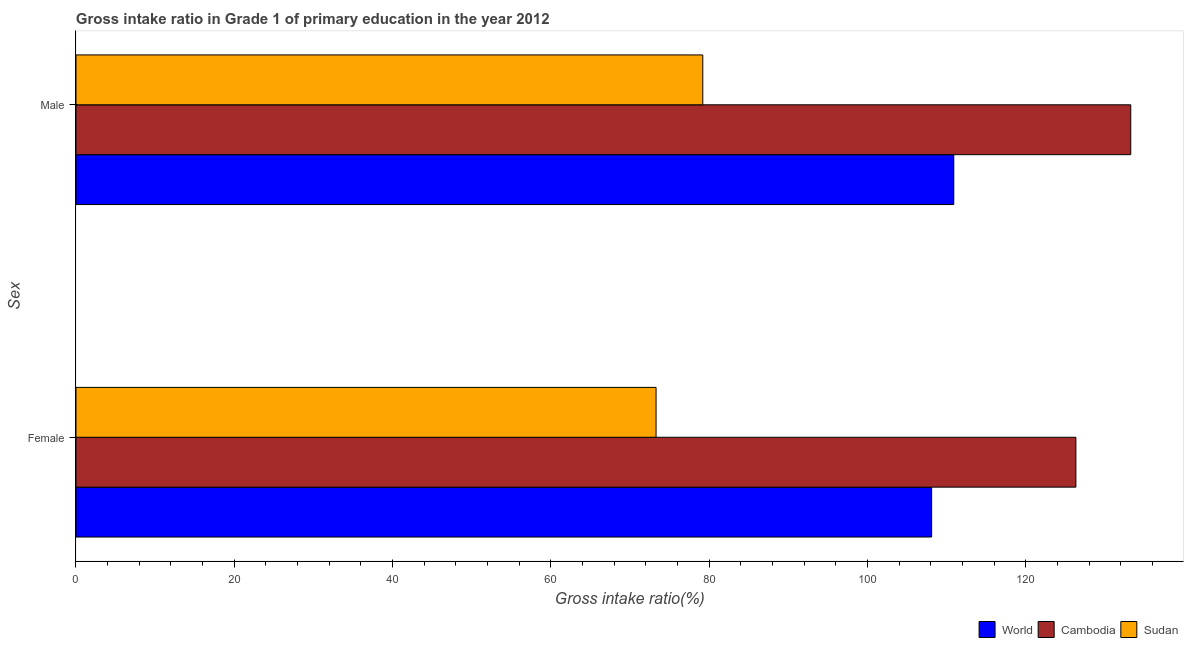Are the number of bars per tick equal to the number of legend labels?
Make the answer very short. Yes. How many bars are there on the 2nd tick from the top?
Keep it short and to the point. 3. What is the label of the 2nd group of bars from the top?
Make the answer very short. Female. What is the gross intake ratio(male) in Sudan?
Provide a short and direct response. 79.19. Across all countries, what is the maximum gross intake ratio(male)?
Keep it short and to the point. 133.27. Across all countries, what is the minimum gross intake ratio(female)?
Ensure brevity in your answer.  73.29. In which country was the gross intake ratio(female) maximum?
Your answer should be very brief. Cambodia. In which country was the gross intake ratio(female) minimum?
Keep it short and to the point. Sudan. What is the total gross intake ratio(male) in the graph?
Provide a succinct answer. 323.36. What is the difference between the gross intake ratio(female) in World and that in Sudan?
Offer a terse response. 34.82. What is the difference between the gross intake ratio(male) in Sudan and the gross intake ratio(female) in World?
Give a very brief answer. -28.92. What is the average gross intake ratio(male) per country?
Your response must be concise. 107.79. What is the difference between the gross intake ratio(male) and gross intake ratio(female) in World?
Provide a short and direct response. 2.8. What is the ratio of the gross intake ratio(male) in Cambodia to that in Sudan?
Offer a very short reply. 1.68. In how many countries, is the gross intake ratio(female) greater than the average gross intake ratio(female) taken over all countries?
Your answer should be compact. 2. What does the 2nd bar from the bottom in Male represents?
Keep it short and to the point. Cambodia. How many bars are there?
Your answer should be compact. 6. Are the values on the major ticks of X-axis written in scientific E-notation?
Offer a very short reply. No. Does the graph contain any zero values?
Your answer should be very brief. No. Where does the legend appear in the graph?
Ensure brevity in your answer.  Bottom right. What is the title of the graph?
Your answer should be very brief. Gross intake ratio in Grade 1 of primary education in the year 2012. What is the label or title of the X-axis?
Ensure brevity in your answer.  Gross intake ratio(%). What is the label or title of the Y-axis?
Your response must be concise. Sex. What is the Gross intake ratio(%) in World in Female?
Offer a very short reply. 108.11. What is the Gross intake ratio(%) in Cambodia in Female?
Provide a succinct answer. 126.33. What is the Gross intake ratio(%) in Sudan in Female?
Provide a short and direct response. 73.29. What is the Gross intake ratio(%) in World in Male?
Give a very brief answer. 110.91. What is the Gross intake ratio(%) of Cambodia in Male?
Provide a short and direct response. 133.27. What is the Gross intake ratio(%) in Sudan in Male?
Offer a terse response. 79.19. Across all Sex, what is the maximum Gross intake ratio(%) in World?
Make the answer very short. 110.91. Across all Sex, what is the maximum Gross intake ratio(%) in Cambodia?
Offer a very short reply. 133.27. Across all Sex, what is the maximum Gross intake ratio(%) in Sudan?
Provide a short and direct response. 79.19. Across all Sex, what is the minimum Gross intake ratio(%) of World?
Provide a succinct answer. 108.11. Across all Sex, what is the minimum Gross intake ratio(%) in Cambodia?
Provide a short and direct response. 126.33. Across all Sex, what is the minimum Gross intake ratio(%) of Sudan?
Provide a succinct answer. 73.29. What is the total Gross intake ratio(%) of World in the graph?
Ensure brevity in your answer.  219.01. What is the total Gross intake ratio(%) in Cambodia in the graph?
Ensure brevity in your answer.  259.6. What is the total Gross intake ratio(%) of Sudan in the graph?
Give a very brief answer. 152.48. What is the difference between the Gross intake ratio(%) of World in Female and that in Male?
Provide a succinct answer. -2.8. What is the difference between the Gross intake ratio(%) in Cambodia in Female and that in Male?
Provide a succinct answer. -6.93. What is the difference between the Gross intake ratio(%) in Sudan in Female and that in Male?
Make the answer very short. -5.9. What is the difference between the Gross intake ratio(%) of World in Female and the Gross intake ratio(%) of Cambodia in Male?
Make the answer very short. -25.16. What is the difference between the Gross intake ratio(%) of World in Female and the Gross intake ratio(%) of Sudan in Male?
Your response must be concise. 28.92. What is the difference between the Gross intake ratio(%) of Cambodia in Female and the Gross intake ratio(%) of Sudan in Male?
Ensure brevity in your answer.  47.14. What is the average Gross intake ratio(%) in World per Sex?
Ensure brevity in your answer.  109.51. What is the average Gross intake ratio(%) of Cambodia per Sex?
Provide a succinct answer. 129.8. What is the average Gross intake ratio(%) of Sudan per Sex?
Keep it short and to the point. 76.24. What is the difference between the Gross intake ratio(%) of World and Gross intake ratio(%) of Cambodia in Female?
Ensure brevity in your answer.  -18.23. What is the difference between the Gross intake ratio(%) of World and Gross intake ratio(%) of Sudan in Female?
Provide a short and direct response. 34.82. What is the difference between the Gross intake ratio(%) of Cambodia and Gross intake ratio(%) of Sudan in Female?
Provide a short and direct response. 53.04. What is the difference between the Gross intake ratio(%) of World and Gross intake ratio(%) of Cambodia in Male?
Give a very brief answer. -22.36. What is the difference between the Gross intake ratio(%) of World and Gross intake ratio(%) of Sudan in Male?
Offer a very short reply. 31.71. What is the difference between the Gross intake ratio(%) of Cambodia and Gross intake ratio(%) of Sudan in Male?
Provide a short and direct response. 54.07. What is the ratio of the Gross intake ratio(%) in World in Female to that in Male?
Provide a succinct answer. 0.97. What is the ratio of the Gross intake ratio(%) of Cambodia in Female to that in Male?
Offer a terse response. 0.95. What is the ratio of the Gross intake ratio(%) in Sudan in Female to that in Male?
Provide a succinct answer. 0.93. What is the difference between the highest and the second highest Gross intake ratio(%) of World?
Your answer should be very brief. 2.8. What is the difference between the highest and the second highest Gross intake ratio(%) of Cambodia?
Offer a terse response. 6.93. What is the difference between the highest and the second highest Gross intake ratio(%) of Sudan?
Your answer should be very brief. 5.9. What is the difference between the highest and the lowest Gross intake ratio(%) in World?
Provide a succinct answer. 2.8. What is the difference between the highest and the lowest Gross intake ratio(%) of Cambodia?
Offer a terse response. 6.93. What is the difference between the highest and the lowest Gross intake ratio(%) in Sudan?
Your answer should be compact. 5.9. 